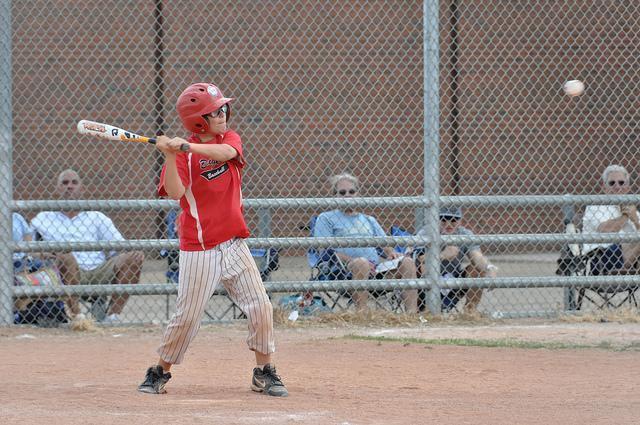How many people can be seen?
Give a very brief answer. 6. How many cats have gray on their fur?
Give a very brief answer. 0. 